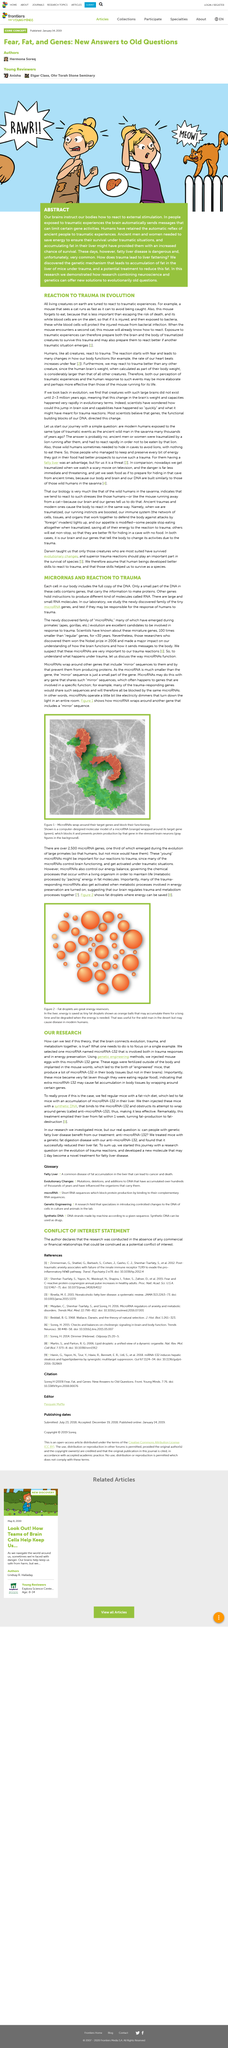List a handful of essential elements in this visual. Figure 2 illustrates fat droplets, which serve as a storage of energy that can be conserved for future use. MicroRNAs and target genes on DNA are represented respectively by red and green in figure 1. The reaction of a mouse in response to a traumatic experience is often compared to the behavior of an animal when it sees a cat. This analogy is used to illustrate the traumatic experience of the mouse. MicroRNAs play a critical role in controlling brain functioning and becoming activated under traumatic situations. Large brains have been existing for approximately 2-3 million years. 